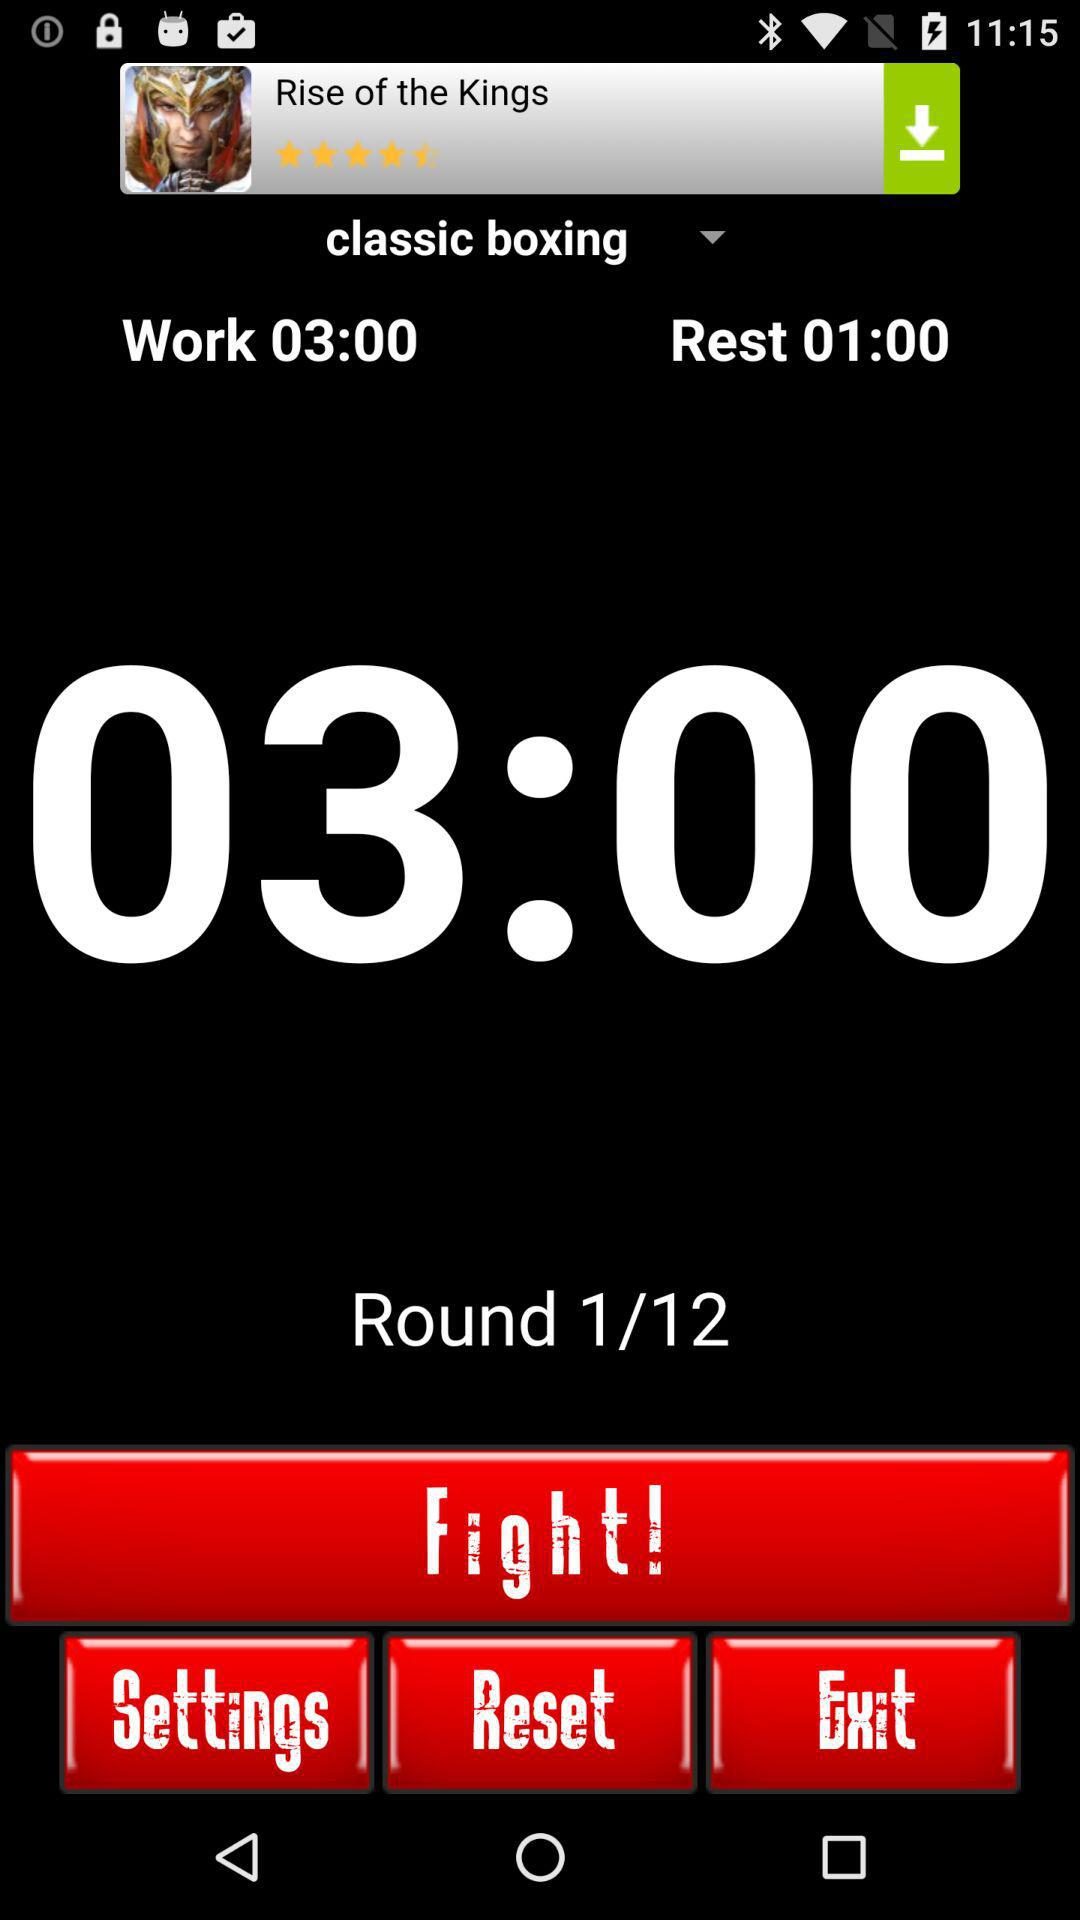How many rounds in total are there in "classic boxing"? There are a total of 12 rounds. 